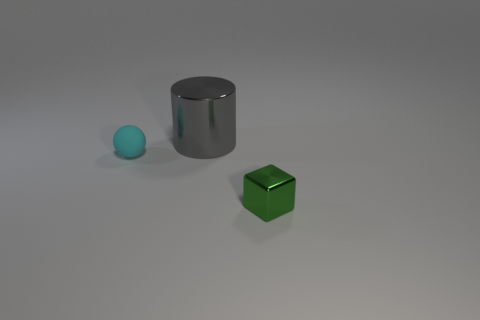Add 2 cyan rubber spheres. How many objects exist? 5 Subtract all blocks. How many objects are left? 2 Subtract all gray metal things. Subtract all small red metallic blocks. How many objects are left? 2 Add 3 tiny rubber spheres. How many tiny rubber spheres are left? 4 Add 3 large purple matte cylinders. How many large purple matte cylinders exist? 3 Subtract 0 brown spheres. How many objects are left? 3 